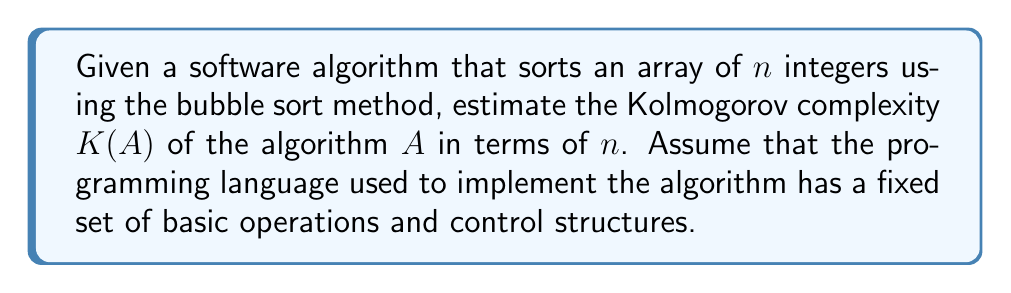Show me your answer to this math problem. To estimate the Kolmogorov complexity $K(A)$ of the bubble sort algorithm $A$, we need to consider the shortest possible description of the algorithm in a given programming language. Let's break this down step-by-step:

1. The basic structure of bubble sort consists of two nested loops:
   - Outer loop: Iterates $n-1$ times
   - Inner loop: Compares and swaps adjacent elements

2. The core operations in the algorithm are:
   - Comparison of two elements
   - Swapping of two elements
   - Incrementing loop counters

3. We also need to consider the initialization of variables and the array.

4. Assuming a concise programming language, we can estimate the number of bits required to describe each component:
   - Outer loop structure: $O(\log n)$ bits (to specify the number of iterations)
   - Inner loop structure: $O(\log n)$ bits (to specify the number of comparisons)
   - Comparison operation: $O(1)$ bits
   - Swap operation: $O(1)$ bits
   - Variable declarations and initializations: $O(1)$ bits

5. The total description length will be dominated by the loop structures, as they depend on $n$. The constant-size operations contribute a fixed amount regardless of input size.

6. Therefore, we can estimate the Kolmogorov complexity as:

   $$K(A) = O(\log n) + O(\log n) + O(1) = O(\log n)$$

7. This logarithmic complexity arises because we need only to describe the structure of the algorithm, which scales logarithmically with the input size, rather than describing the full input or output.

8. It's important to note that this is an upper bound on the Kolmogorov complexity. There might be even more concise descriptions of the algorithm, but they cannot be significantly shorter than this estimate.
Answer: $K(A) = O(\log n)$ 